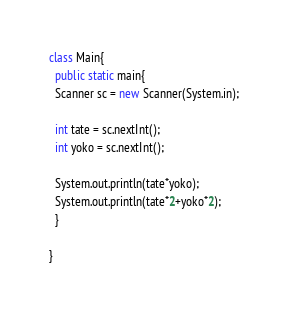<code> <loc_0><loc_0><loc_500><loc_500><_Java_>class Main{
  public static main{
  Scanner sc = new Scanner(System.in);
  
  int tate = sc.nextInt();
  int yoko = sc.nextInt();
  
  System.out.println(tate*yoko);
  System.out.println(tate*2+yoko*2);
  }

}
</code> 